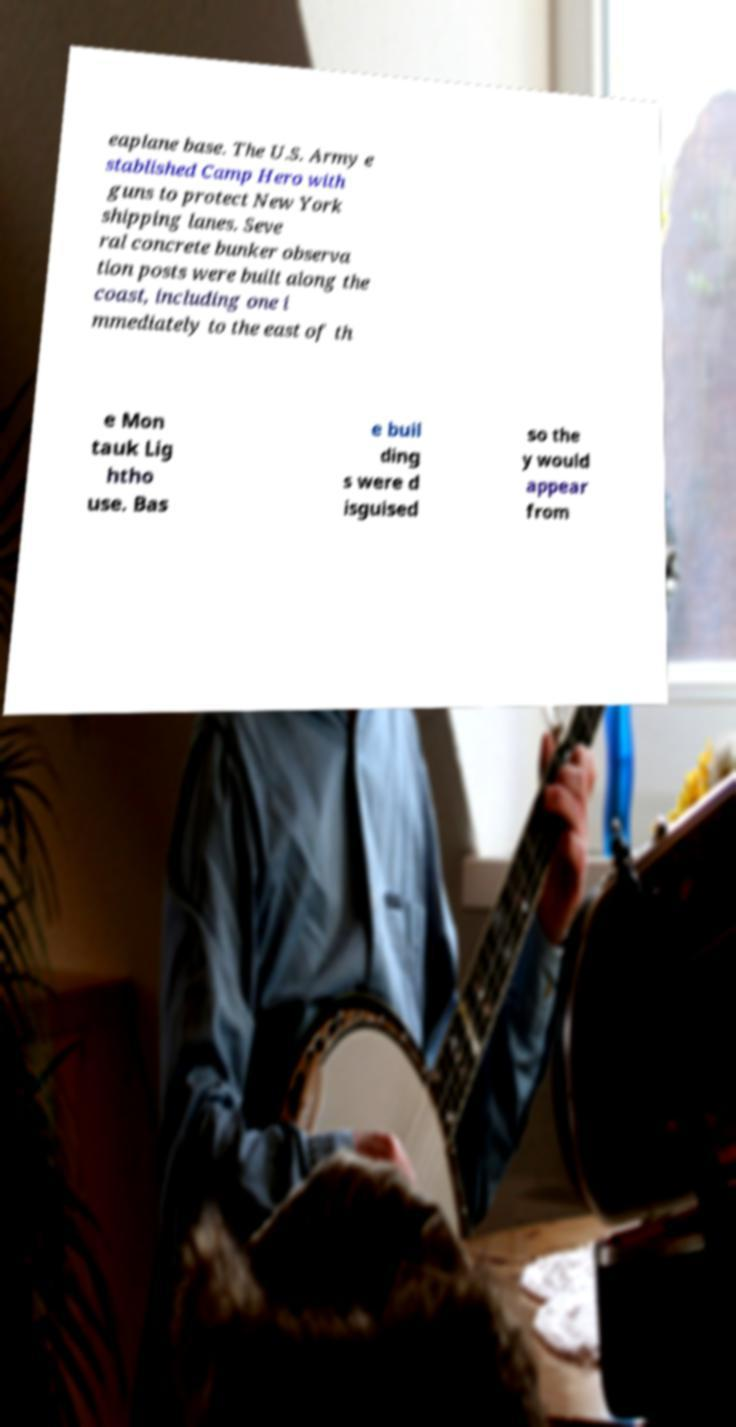I need the written content from this picture converted into text. Can you do that? eaplane base. The U.S. Army e stablished Camp Hero with guns to protect New York shipping lanes. Seve ral concrete bunker observa tion posts were built along the coast, including one i mmediately to the east of th e Mon tauk Lig htho use. Bas e buil ding s were d isguised so the y would appear from 